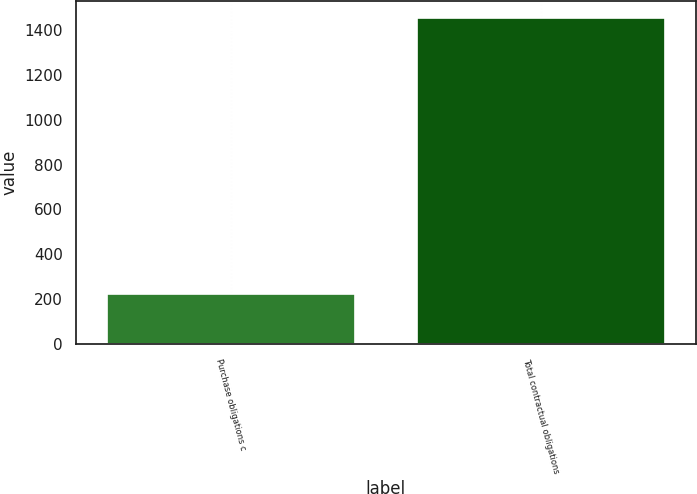<chart> <loc_0><loc_0><loc_500><loc_500><bar_chart><fcel>Purchase obligations c<fcel>Total contractual obligations<nl><fcel>223<fcel>1455<nl></chart> 